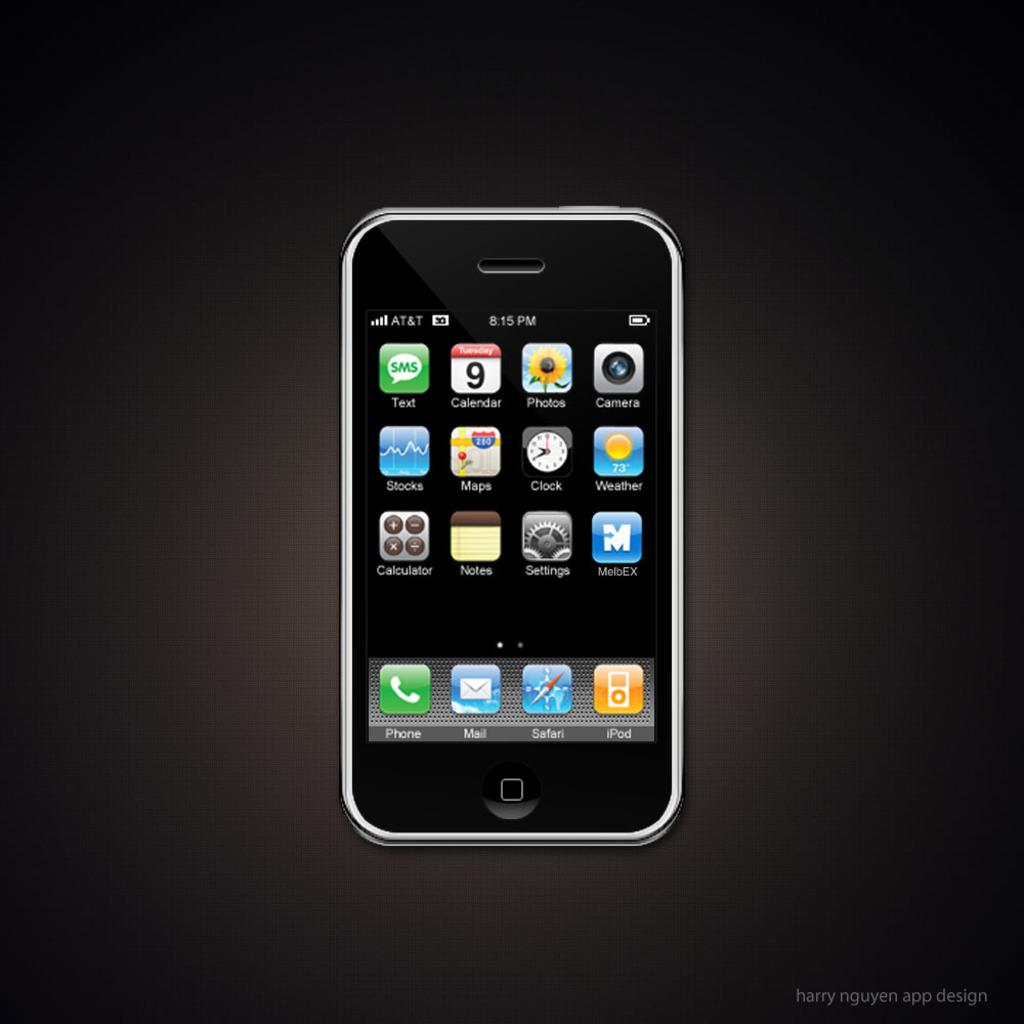<image>
Relay a brief, clear account of the picture shown. a display of a cellphone with icons for SAFARI And IPod 